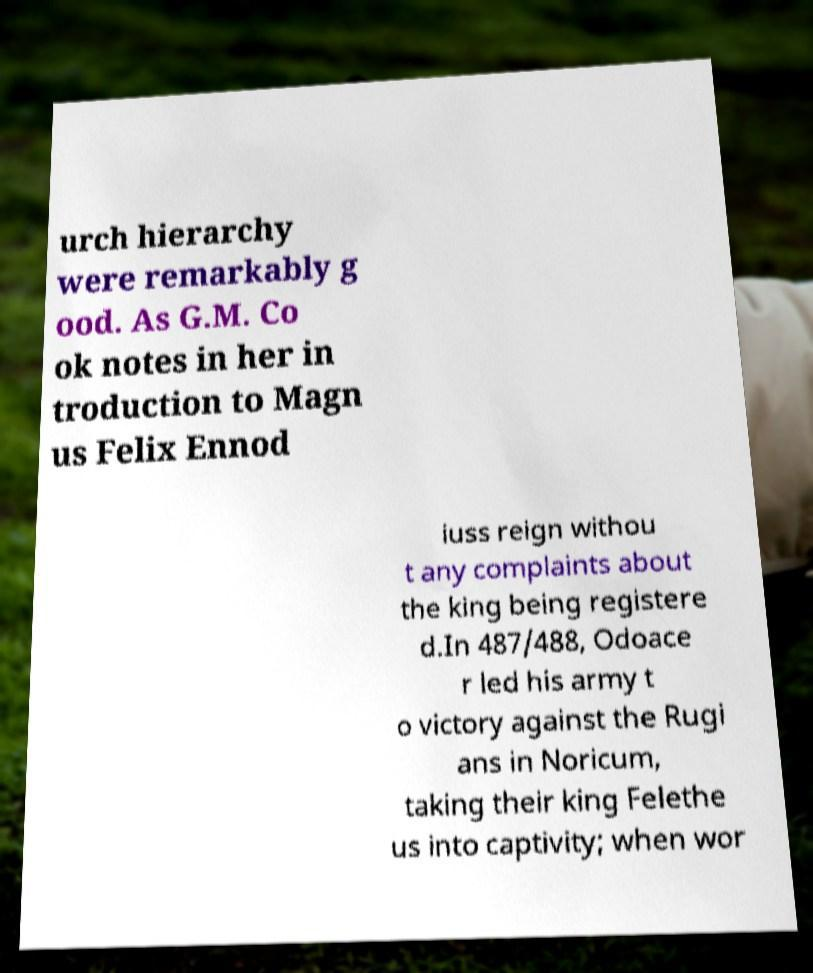What messages or text are displayed in this image? I need them in a readable, typed format. urch hierarchy were remarkably g ood. As G.M. Co ok notes in her in troduction to Magn us Felix Ennod iuss reign withou t any complaints about the king being registere d.In 487/488, Odoace r led his army t o victory against the Rugi ans in Noricum, taking their king Felethe us into captivity; when wor 